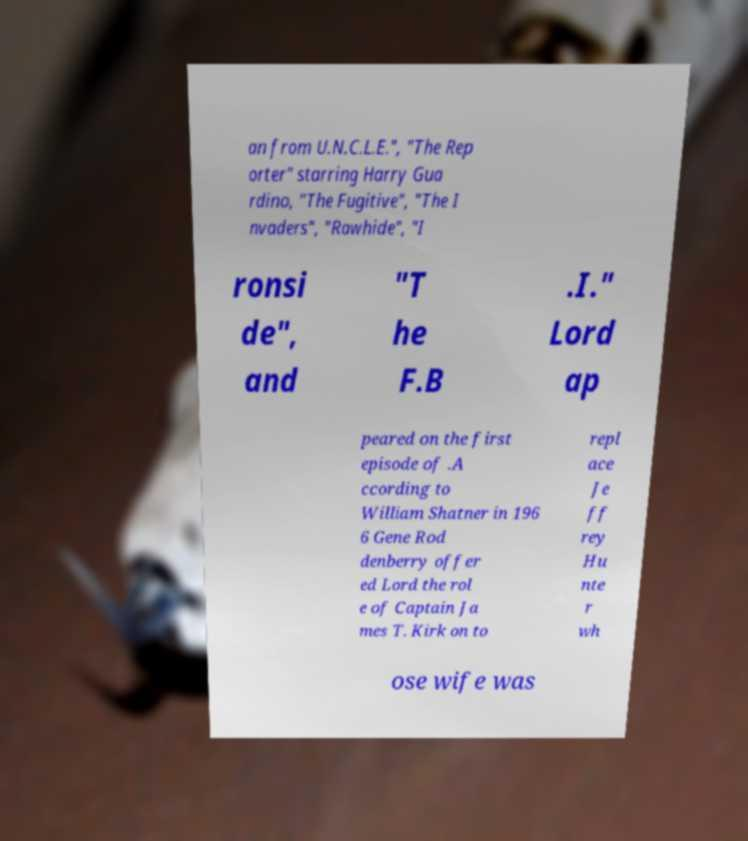Can you accurately transcribe the text from the provided image for me? an from U.N.C.L.E.", "The Rep orter" starring Harry Gua rdino, "The Fugitive", "The I nvaders", "Rawhide", "I ronsi de", and "T he F.B .I." Lord ap peared on the first episode of .A ccording to William Shatner in 196 6 Gene Rod denberry offer ed Lord the rol e of Captain Ja mes T. Kirk on to repl ace Je ff rey Hu nte r wh ose wife was 